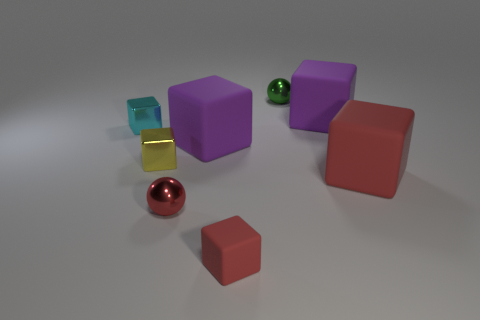What can be inferred about the lighting condition in this image? The lighting appears to be coming from above as indicated by the shadows cast directly underneath the objects. The diffuse nature of the shadows suggests a soft, ambient light source that evenly illuminates the scene without creating harsh contrasts or strong highlights.  Can you speculate about the size of the objects based on their appearance? Without a reference object for scale it is challenging to ascertain their exact sizes. However, judging by their relative proportions and assuming the scene depicts a typical setup, the cubes could be roughly the size of dice, whereas the sphere and the bar might be slightly smaller, comparable to marbles or similar small objects. 